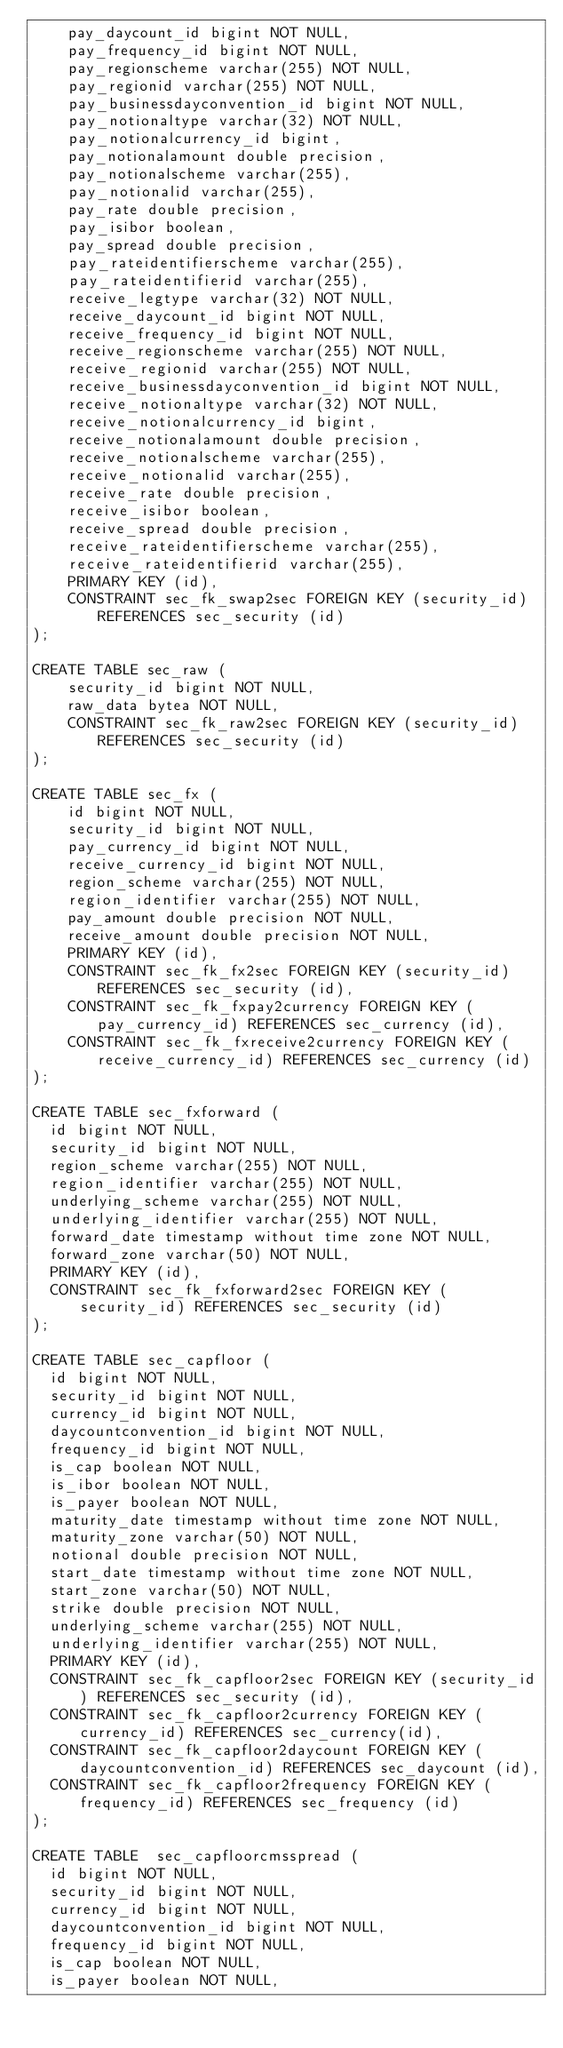<code> <loc_0><loc_0><loc_500><loc_500><_SQL_>    pay_daycount_id bigint NOT NULL,
    pay_frequency_id bigint NOT NULL,
    pay_regionscheme varchar(255) NOT NULL,
    pay_regionid varchar(255) NOT NULL,
    pay_businessdayconvention_id bigint NOT NULL,
    pay_notionaltype varchar(32) NOT NULL,
    pay_notionalcurrency_id bigint,
    pay_notionalamount double precision,
    pay_notionalscheme varchar(255),
    pay_notionalid varchar(255),
    pay_rate double precision,
    pay_isibor boolean,
    pay_spread double precision,
    pay_rateidentifierscheme varchar(255),
    pay_rateidentifierid varchar(255),
    receive_legtype varchar(32) NOT NULL,
    receive_daycount_id bigint NOT NULL,
    receive_frequency_id bigint NOT NULL,
    receive_regionscheme varchar(255) NOT NULL,
    receive_regionid varchar(255) NOT NULL,
    receive_businessdayconvention_id bigint NOT NULL,
    receive_notionaltype varchar(32) NOT NULL,
    receive_notionalcurrency_id bigint,
    receive_notionalamount double precision,
    receive_notionalscheme varchar(255),
    receive_notionalid varchar(255),
    receive_rate double precision,
    receive_isibor boolean,
    receive_spread double precision,
    receive_rateidentifierscheme varchar(255),
    receive_rateidentifierid varchar(255),
    PRIMARY KEY (id),
    CONSTRAINT sec_fk_swap2sec FOREIGN KEY (security_id) REFERENCES sec_security (id)
);

CREATE TABLE sec_raw (
    security_id bigint NOT NULL,
    raw_data bytea NOT NULL,
    CONSTRAINT sec_fk_raw2sec FOREIGN KEY (security_id) REFERENCES sec_security (id)
);

CREATE TABLE sec_fx (
    id bigint NOT NULL,
    security_id bigint NOT NULL,
    pay_currency_id bigint NOT NULL,
    receive_currency_id bigint NOT NULL,
    region_scheme varchar(255) NOT NULL,
    region_identifier varchar(255) NOT NULL,
    pay_amount double precision NOT NULL,
    receive_amount double precision NOT NULL,
    PRIMARY KEY (id),
    CONSTRAINT sec_fk_fx2sec FOREIGN KEY (security_id) REFERENCES sec_security (id),
    CONSTRAINT sec_fk_fxpay2currency FOREIGN KEY (pay_currency_id) REFERENCES sec_currency (id),
    CONSTRAINT sec_fk_fxreceive2currency FOREIGN KEY (receive_currency_id) REFERENCES sec_currency (id)
);

CREATE TABLE sec_fxforward (
  id bigint NOT NULL,
  security_id bigint NOT NULL,
  region_scheme varchar(255) NOT NULL,
  region_identifier varchar(255) NOT NULL,
  underlying_scheme varchar(255) NOT NULL,
  underlying_identifier varchar(255) NOT NULL,
  forward_date timestamp without time zone NOT NULL,
  forward_zone varchar(50) NOT NULL,
  PRIMARY KEY (id),
  CONSTRAINT sec_fk_fxforward2sec FOREIGN KEY (security_id) REFERENCES sec_security (id)
);

CREATE TABLE sec_capfloor (
  id bigint NOT NULL,
  security_id bigint NOT NULL,
  currency_id bigint NOT NULL,
  daycountconvention_id bigint NOT NULL,
  frequency_id bigint NOT NULL,
  is_cap boolean NOT NULL,
  is_ibor boolean NOT NULL,
  is_payer boolean NOT NULL,
  maturity_date timestamp without time zone NOT NULL,
  maturity_zone varchar(50) NOT NULL,
  notional double precision NOT NULL,
  start_date timestamp without time zone NOT NULL,
  start_zone varchar(50) NOT NULL,
  strike double precision NOT NULL,
  underlying_scheme varchar(255) NOT NULL,
  underlying_identifier varchar(255) NOT NULL,
  PRIMARY KEY (id),
  CONSTRAINT sec_fk_capfloor2sec FOREIGN KEY (security_id) REFERENCES sec_security (id),
  CONSTRAINT sec_fk_capfloor2currency FOREIGN KEY (currency_id) REFERENCES sec_currency(id),
  CONSTRAINT sec_fk_capfloor2daycount FOREIGN KEY (daycountconvention_id) REFERENCES sec_daycount (id),
  CONSTRAINT sec_fk_capfloor2frequency FOREIGN KEY (frequency_id) REFERENCES sec_frequency (id)
);

CREATE TABLE  sec_capfloorcmsspread (
  id bigint NOT NULL,
  security_id bigint NOT NULL,
  currency_id bigint NOT NULL,
  daycountconvention_id bigint NOT NULL,
  frequency_id bigint NOT NULL,
  is_cap boolean NOT NULL,
  is_payer boolean NOT NULL,</code> 